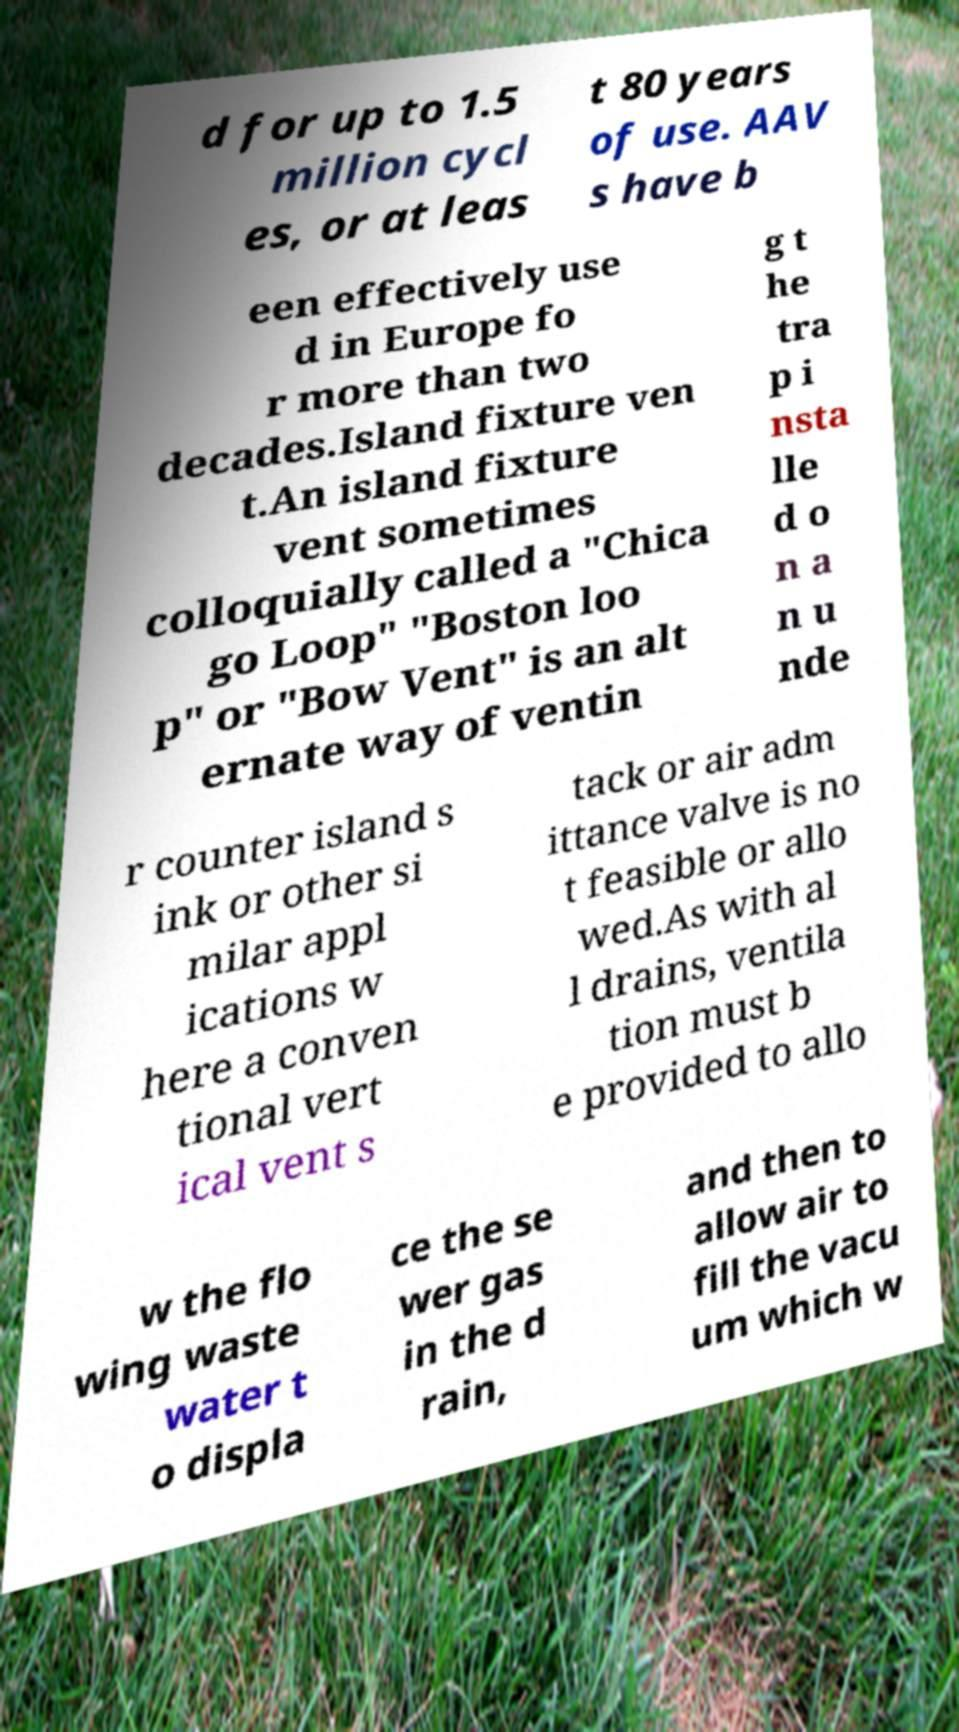Can you read and provide the text displayed in the image?This photo seems to have some interesting text. Can you extract and type it out for me? d for up to 1.5 million cycl es, or at leas t 80 years of use. AAV s have b een effectively use d in Europe fo r more than two decades.Island fixture ven t.An island fixture vent sometimes colloquially called a "Chica go Loop" "Boston loo p" or "Bow Vent" is an alt ernate way of ventin g t he tra p i nsta lle d o n a n u nde r counter island s ink or other si milar appl ications w here a conven tional vert ical vent s tack or air adm ittance valve is no t feasible or allo wed.As with al l drains, ventila tion must b e provided to allo w the flo wing waste water t o displa ce the se wer gas in the d rain, and then to allow air to fill the vacu um which w 